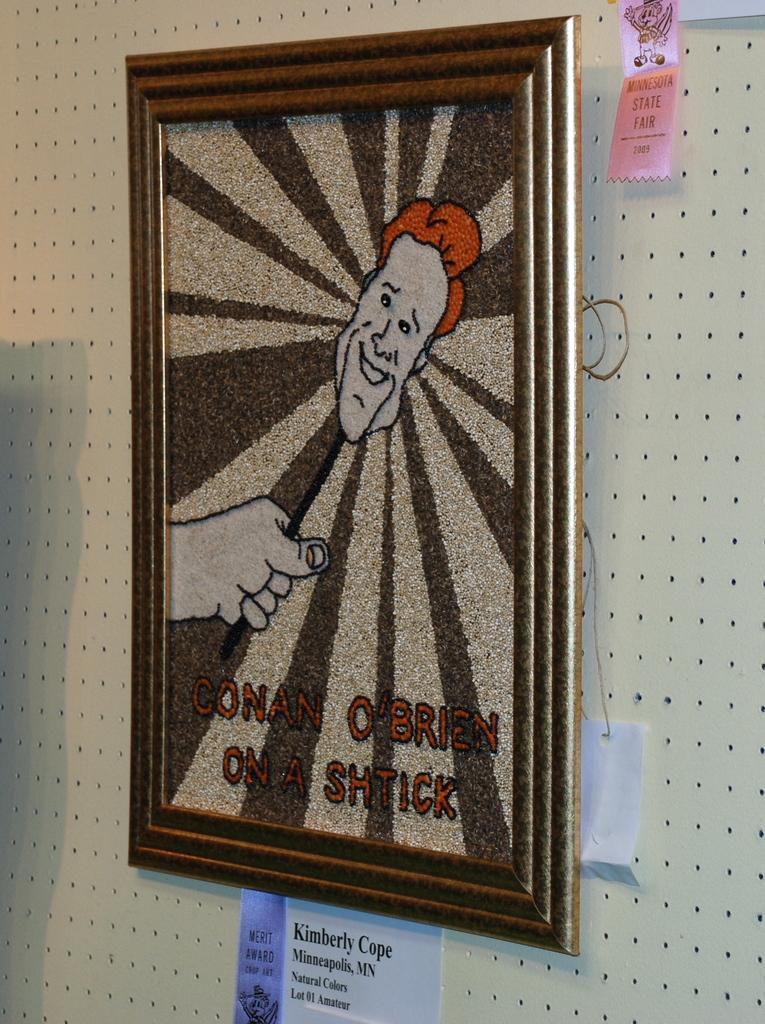<image>
Offer a succinct explanation of the picture presented. A FRAMED PICTURE OF CONAN OBRIEN ON A SHTICK 